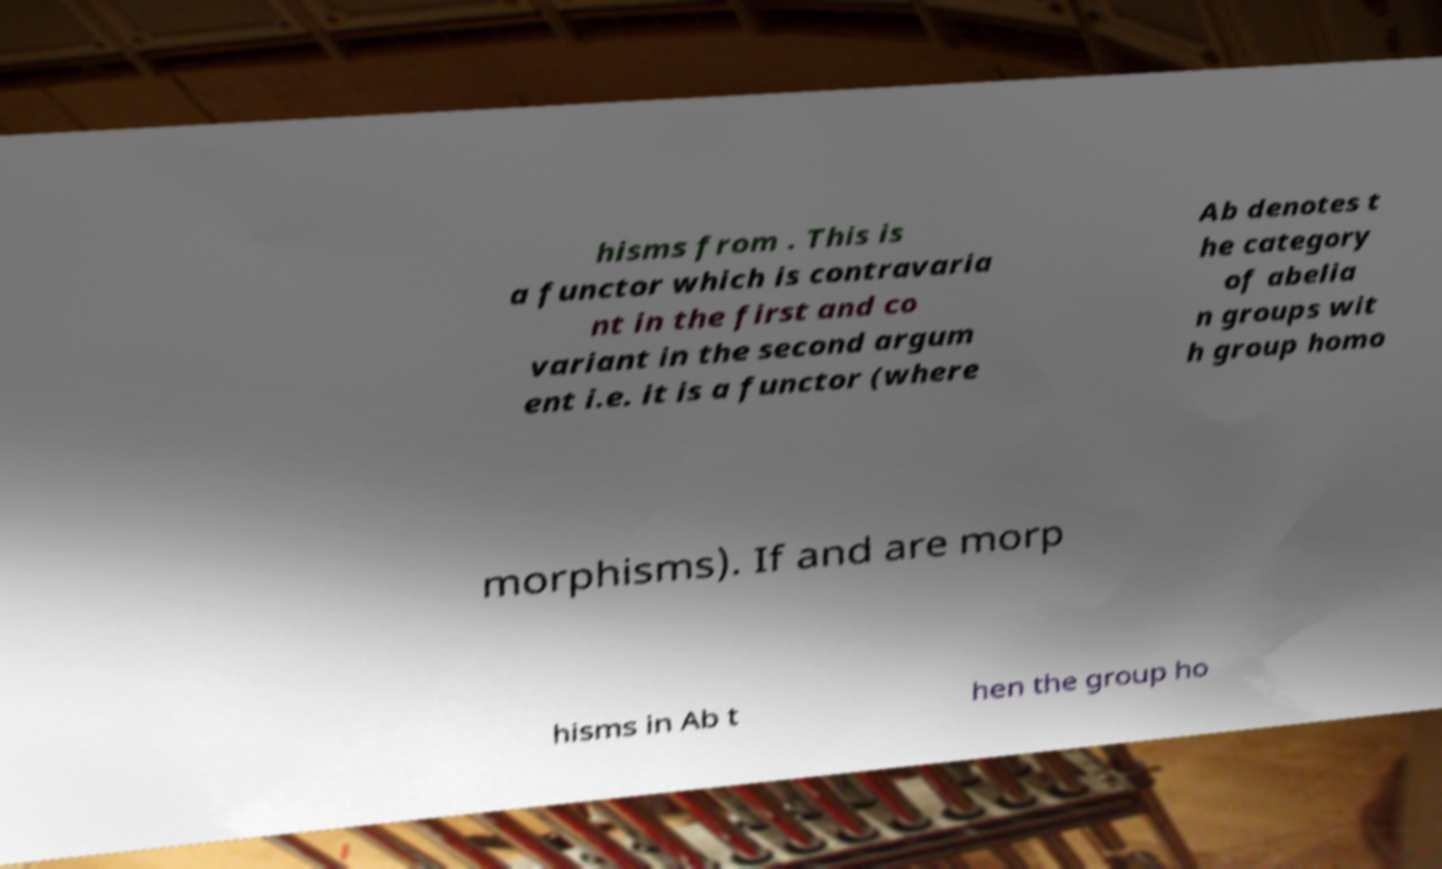I need the written content from this picture converted into text. Can you do that? hisms from . This is a functor which is contravaria nt in the first and co variant in the second argum ent i.e. it is a functor (where Ab denotes t he category of abelia n groups wit h group homo morphisms). If and are morp hisms in Ab t hen the group ho 